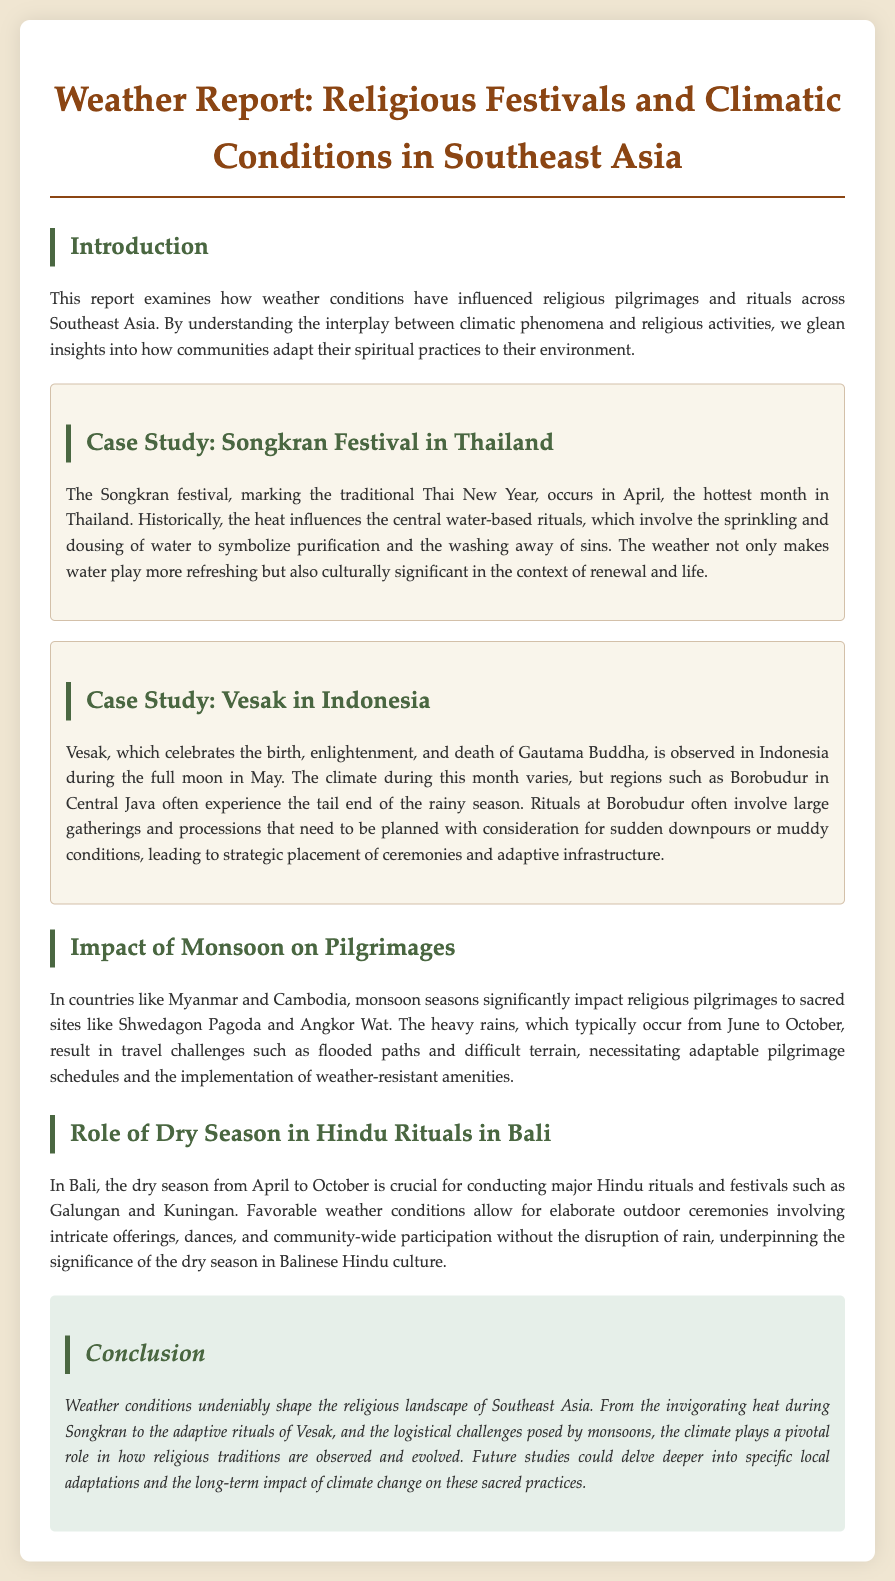What festival marks the traditional Thai New Year? The Songkran festival marks the traditional Thai New Year in April.
Answer: Songkran When is Vesak observed in Indonesia? Vesak is observed during the full moon in May.
Answer: May What climatic condition influences the rituals at Borobudur during Vesak? The tail end of the rainy season affects the rituals at Borobudur.
Answer: Rainy season Which sacred site in Myanmar is mentioned in relation to monsoon impacts? Shwedagon Pagoda is a sacred site in Myanmar mentioned in the document.
Answer: Shwedagon Pagoda What is the significance of the dry season in Bali for Hindu rituals? The dry season allows for elaborate outdoor ceremonies without rain disruption.
Answer: Outdoor ceremonies What are the major Hindu rituals celebrated in Bali? The major Hindu rituals in Bali are Galungan and Kuningan.
Answer: Galungan and Kuningan During which months does the heavy rainfall typically occur in Southeast Asia? Heavy rains typically occur from June to October.
Answer: June to October What is a key adaptive strategy for religious gatherings during heavy rains? The strategic placement of ceremonies and adaptive infrastructure is a key strategy.
Answer: Adaptive infrastructure 